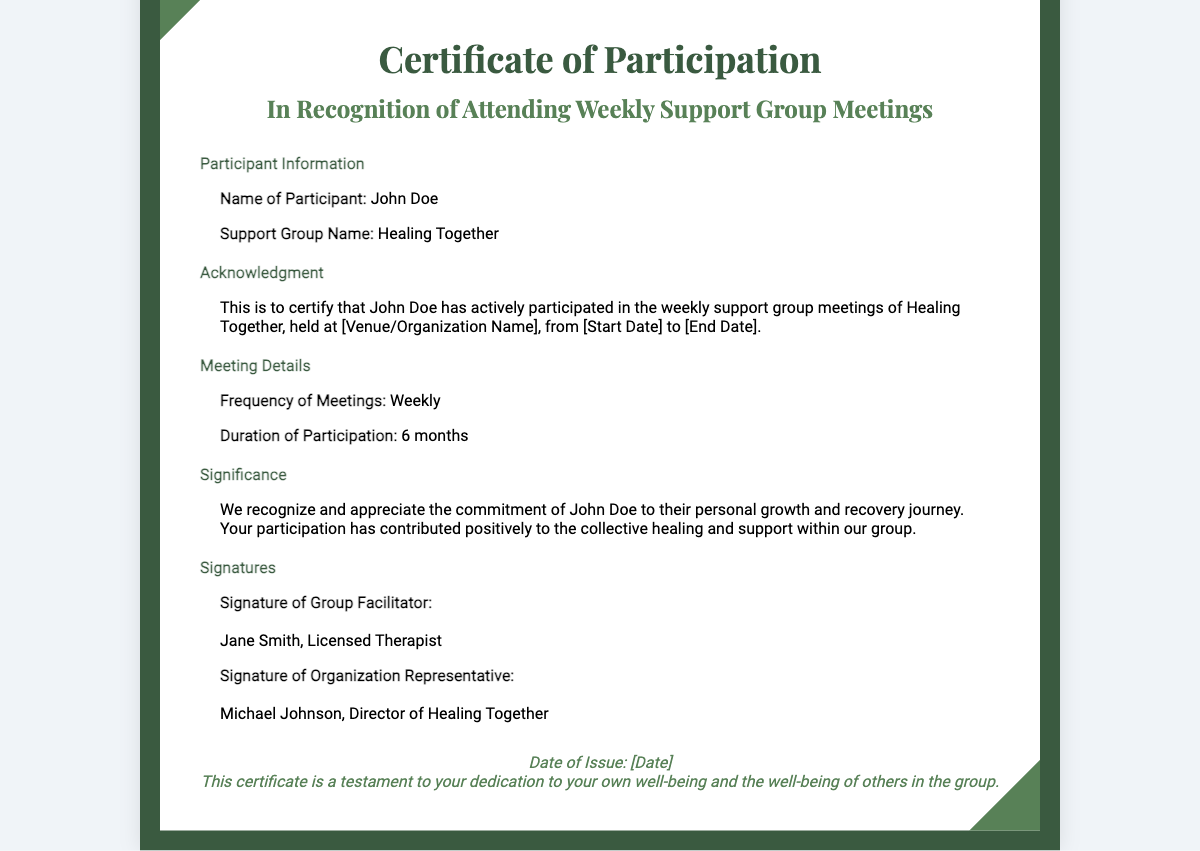What is the name of the participant? The document includes a section with participant information where the name is listed.
Answer: John Doe What is the title of the certificate? The title appears prominently at the top of the document, indicating the purpose of the certificate.
Answer: Certificate of Participation What is the name of the support group? The support group name is provided in the participant information section of the document.
Answer: Healing Together What is the duration of participation? The duration is specified in the meeting details section, indicating the length of involvement in the support group.
Answer: 6 months Who is the group facilitator? The document names the group facilitator in the signatures section.
Answer: Jane Smith What is the frequency of the meetings? The frequency is mentioned explicitly in the meeting details section.
Answer: Weekly What does the certificate acknowledge? The acknowledgment section specifies what the certificate is certifying regarding the participant's involvement.
Answer: Participation in weekly support group meetings What is the significance of the participant's involvement? The significance section explains the impact of the participant's commitment on both personal growth and the group's collective healing.
Answer: Commitment to personal growth and recovery journey What is the date of issue for the certificate? The footer mentions a placeholder for the date, indicating when the certificate was issued.
Answer: [Date] 